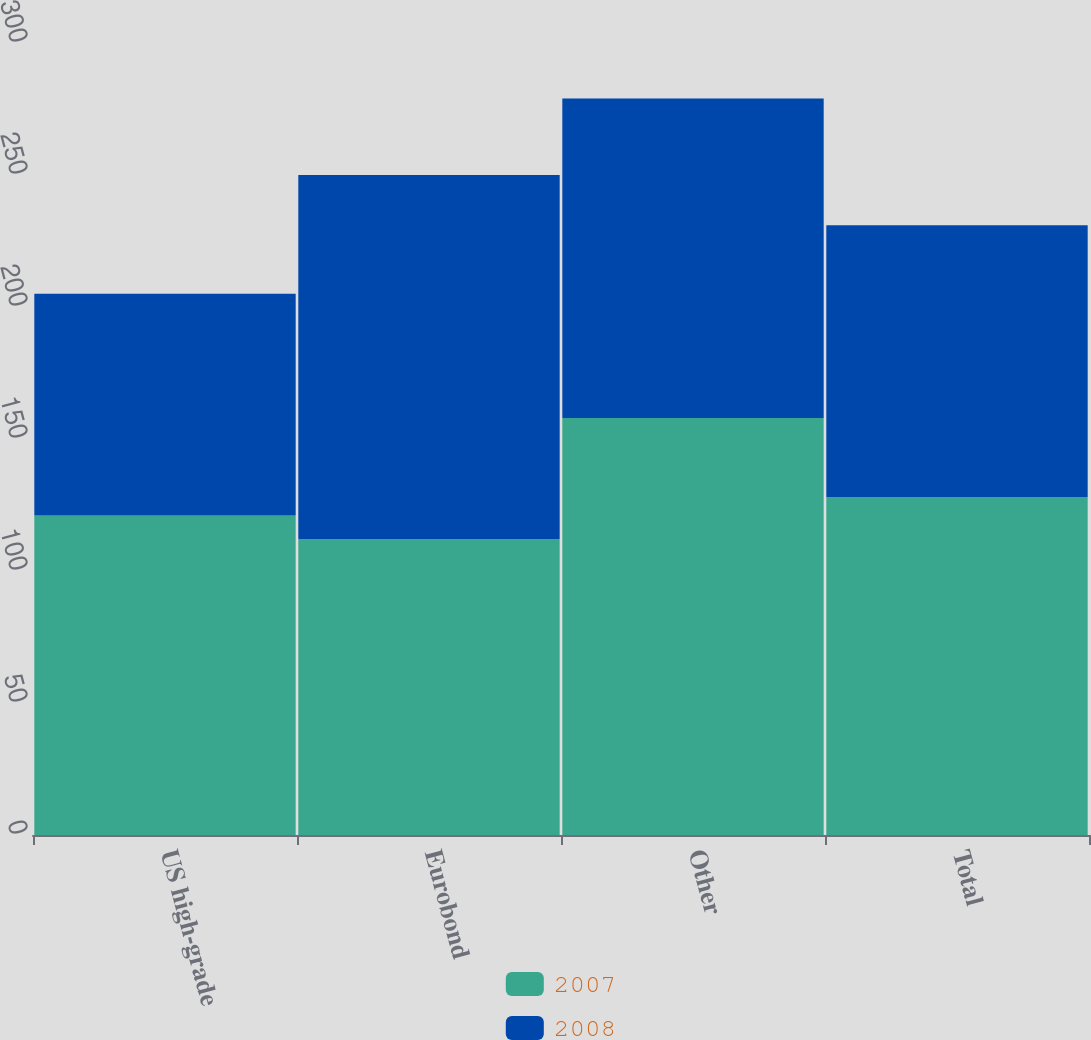Convert chart to OTSL. <chart><loc_0><loc_0><loc_500><loc_500><stacked_bar_chart><ecel><fcel>US high-grade<fcel>Eurobond<fcel>Other<fcel>Total<nl><fcel>2007<fcel>121<fcel>112<fcel>158<fcel>128<nl><fcel>2008<fcel>84<fcel>138<fcel>121<fcel>103<nl></chart> 